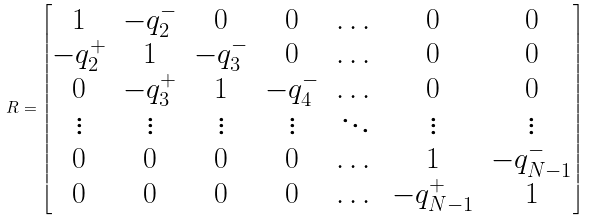Convert formula to latex. <formula><loc_0><loc_0><loc_500><loc_500>R = \begin{bmatrix} 1 & - q ^ { - } _ { 2 } & 0 & 0 & \dots & 0 & 0 \\ - q ^ { + } _ { 2 } & 1 & - q ^ { - } _ { 3 } & 0 & \dots & 0 & 0 \\ 0 & - q ^ { + } _ { 3 } & 1 & - q ^ { - } _ { 4 } & \dots & 0 & 0 \\ \vdots & \vdots & \vdots & \vdots & \ddots & \vdots & \vdots \\ 0 & 0 & 0 & 0 & \dots & 1 & - q ^ { - } _ { N - 1 } \\ 0 & 0 & 0 & 0 & \dots & - q ^ { + } _ { N - 1 } & 1 \end{bmatrix}</formula> 